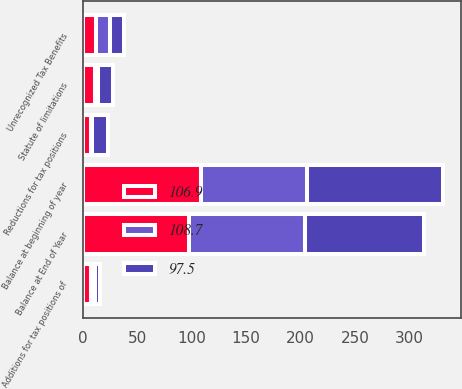Convert chart to OTSL. <chart><loc_0><loc_0><loc_500><loc_500><stacked_bar_chart><ecel><fcel>Unrecognized Tax Benefits<fcel>Balance at beginning of year<fcel>Additions for tax positions of<fcel>Reductions for tax positions<fcel>Statute of limitations<fcel>Balance at End of Year<nl><fcel>108.7<fcel>12.6<fcel>97.5<fcel>3.8<fcel>0.3<fcel>3<fcel>106.9<nl><fcel>106.9<fcel>12.6<fcel>108.7<fcel>7.5<fcel>7.9<fcel>11.2<fcel>97.5<nl><fcel>97.5<fcel>12.6<fcel>124.3<fcel>4.9<fcel>14.6<fcel>14<fcel>108.7<nl></chart> 